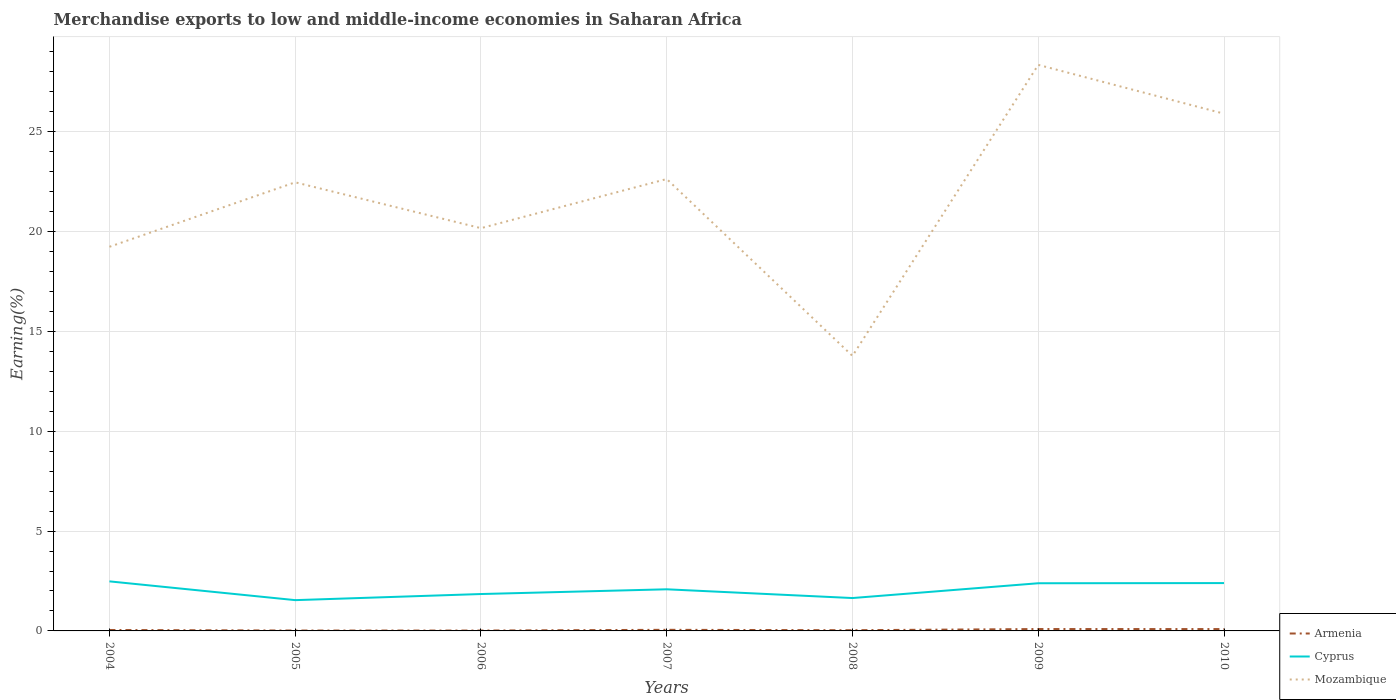Is the number of lines equal to the number of legend labels?
Provide a short and direct response. Yes. Across all years, what is the maximum percentage of amount earned from merchandise exports in Mozambique?
Provide a succinct answer. 13.77. In which year was the percentage of amount earned from merchandise exports in Mozambique maximum?
Provide a short and direct response. 2008. What is the total percentage of amount earned from merchandise exports in Mozambique in the graph?
Provide a short and direct response. -8.18. What is the difference between the highest and the second highest percentage of amount earned from merchandise exports in Cyprus?
Your answer should be compact. 0.94. Is the percentage of amount earned from merchandise exports in Armenia strictly greater than the percentage of amount earned from merchandise exports in Cyprus over the years?
Provide a succinct answer. Yes. How many lines are there?
Ensure brevity in your answer.  3. What is the difference between two consecutive major ticks on the Y-axis?
Keep it short and to the point. 5. Are the values on the major ticks of Y-axis written in scientific E-notation?
Give a very brief answer. No. Does the graph contain any zero values?
Your answer should be very brief. No. Where does the legend appear in the graph?
Your response must be concise. Bottom right. What is the title of the graph?
Provide a short and direct response. Merchandise exports to low and middle-income economies in Saharan Africa. Does "Turks and Caicos Islands" appear as one of the legend labels in the graph?
Provide a succinct answer. No. What is the label or title of the X-axis?
Your answer should be very brief. Years. What is the label or title of the Y-axis?
Give a very brief answer. Earning(%). What is the Earning(%) of Armenia in 2004?
Offer a terse response. 0.05. What is the Earning(%) of Cyprus in 2004?
Ensure brevity in your answer.  2.48. What is the Earning(%) of Mozambique in 2004?
Your answer should be compact. 19.24. What is the Earning(%) in Armenia in 2005?
Your response must be concise. 0.02. What is the Earning(%) of Cyprus in 2005?
Your answer should be very brief. 1.54. What is the Earning(%) of Mozambique in 2005?
Your response must be concise. 22.47. What is the Earning(%) of Armenia in 2006?
Offer a very short reply. 0.02. What is the Earning(%) of Cyprus in 2006?
Offer a terse response. 1.85. What is the Earning(%) of Mozambique in 2006?
Offer a very short reply. 20.17. What is the Earning(%) of Armenia in 2007?
Your answer should be very brief. 0.06. What is the Earning(%) in Cyprus in 2007?
Offer a very short reply. 2.08. What is the Earning(%) in Mozambique in 2007?
Give a very brief answer. 22.64. What is the Earning(%) in Armenia in 2008?
Keep it short and to the point. 0.04. What is the Earning(%) of Cyprus in 2008?
Provide a short and direct response. 1.65. What is the Earning(%) in Mozambique in 2008?
Your response must be concise. 13.77. What is the Earning(%) in Armenia in 2009?
Provide a short and direct response. 0.09. What is the Earning(%) of Cyprus in 2009?
Offer a very short reply. 2.39. What is the Earning(%) in Mozambique in 2009?
Provide a short and direct response. 28.35. What is the Earning(%) of Armenia in 2010?
Your answer should be very brief. 0.09. What is the Earning(%) of Cyprus in 2010?
Your answer should be compact. 2.4. What is the Earning(%) of Mozambique in 2010?
Provide a succinct answer. 25.91. Across all years, what is the maximum Earning(%) of Armenia?
Your answer should be very brief. 0.09. Across all years, what is the maximum Earning(%) in Cyprus?
Offer a terse response. 2.48. Across all years, what is the maximum Earning(%) in Mozambique?
Make the answer very short. 28.35. Across all years, what is the minimum Earning(%) in Armenia?
Make the answer very short. 0.02. Across all years, what is the minimum Earning(%) of Cyprus?
Your answer should be compact. 1.54. Across all years, what is the minimum Earning(%) of Mozambique?
Offer a terse response. 13.77. What is the total Earning(%) in Armenia in the graph?
Keep it short and to the point. 0.36. What is the total Earning(%) in Cyprus in the graph?
Make the answer very short. 14.39. What is the total Earning(%) in Mozambique in the graph?
Provide a succinct answer. 152.56. What is the difference between the Earning(%) of Armenia in 2004 and that in 2005?
Give a very brief answer. 0.03. What is the difference between the Earning(%) in Cyprus in 2004 and that in 2005?
Give a very brief answer. 0.94. What is the difference between the Earning(%) in Mozambique in 2004 and that in 2005?
Ensure brevity in your answer.  -3.23. What is the difference between the Earning(%) in Armenia in 2004 and that in 2006?
Your answer should be compact. 0.03. What is the difference between the Earning(%) of Cyprus in 2004 and that in 2006?
Give a very brief answer. 0.63. What is the difference between the Earning(%) of Mozambique in 2004 and that in 2006?
Offer a terse response. -0.93. What is the difference between the Earning(%) in Armenia in 2004 and that in 2007?
Your answer should be compact. -0.01. What is the difference between the Earning(%) of Cyprus in 2004 and that in 2007?
Ensure brevity in your answer.  0.4. What is the difference between the Earning(%) in Mozambique in 2004 and that in 2007?
Ensure brevity in your answer.  -3.39. What is the difference between the Earning(%) in Armenia in 2004 and that in 2008?
Your answer should be compact. 0.01. What is the difference between the Earning(%) in Cyprus in 2004 and that in 2008?
Offer a terse response. 0.84. What is the difference between the Earning(%) in Mozambique in 2004 and that in 2008?
Provide a succinct answer. 5.47. What is the difference between the Earning(%) of Armenia in 2004 and that in 2009?
Make the answer very short. -0.05. What is the difference between the Earning(%) of Cyprus in 2004 and that in 2009?
Make the answer very short. 0.09. What is the difference between the Earning(%) of Mozambique in 2004 and that in 2009?
Your response must be concise. -9.11. What is the difference between the Earning(%) in Armenia in 2004 and that in 2010?
Keep it short and to the point. -0.05. What is the difference between the Earning(%) of Cyprus in 2004 and that in 2010?
Provide a succinct answer. 0.09. What is the difference between the Earning(%) of Mozambique in 2004 and that in 2010?
Make the answer very short. -6.67. What is the difference between the Earning(%) of Armenia in 2005 and that in 2006?
Offer a terse response. 0. What is the difference between the Earning(%) of Cyprus in 2005 and that in 2006?
Your response must be concise. -0.31. What is the difference between the Earning(%) in Mozambique in 2005 and that in 2006?
Provide a short and direct response. 2.3. What is the difference between the Earning(%) of Armenia in 2005 and that in 2007?
Your answer should be very brief. -0.04. What is the difference between the Earning(%) of Cyprus in 2005 and that in 2007?
Keep it short and to the point. -0.54. What is the difference between the Earning(%) of Mozambique in 2005 and that in 2007?
Offer a terse response. -0.16. What is the difference between the Earning(%) in Armenia in 2005 and that in 2008?
Your response must be concise. -0.02. What is the difference between the Earning(%) of Cyprus in 2005 and that in 2008?
Your response must be concise. -0.1. What is the difference between the Earning(%) in Mozambique in 2005 and that in 2008?
Give a very brief answer. 8.7. What is the difference between the Earning(%) in Armenia in 2005 and that in 2009?
Your response must be concise. -0.07. What is the difference between the Earning(%) of Cyprus in 2005 and that in 2009?
Your answer should be very brief. -0.85. What is the difference between the Earning(%) of Mozambique in 2005 and that in 2009?
Your answer should be compact. -5.88. What is the difference between the Earning(%) in Armenia in 2005 and that in 2010?
Your response must be concise. -0.07. What is the difference between the Earning(%) in Cyprus in 2005 and that in 2010?
Keep it short and to the point. -0.85. What is the difference between the Earning(%) in Mozambique in 2005 and that in 2010?
Make the answer very short. -3.44. What is the difference between the Earning(%) in Armenia in 2006 and that in 2007?
Your answer should be very brief. -0.04. What is the difference between the Earning(%) in Cyprus in 2006 and that in 2007?
Ensure brevity in your answer.  -0.24. What is the difference between the Earning(%) in Mozambique in 2006 and that in 2007?
Ensure brevity in your answer.  -2.46. What is the difference between the Earning(%) in Armenia in 2006 and that in 2008?
Provide a short and direct response. -0.02. What is the difference between the Earning(%) of Cyprus in 2006 and that in 2008?
Provide a short and direct response. 0.2. What is the difference between the Earning(%) in Mozambique in 2006 and that in 2008?
Make the answer very short. 6.4. What is the difference between the Earning(%) in Armenia in 2006 and that in 2009?
Offer a terse response. -0.08. What is the difference between the Earning(%) in Cyprus in 2006 and that in 2009?
Your answer should be very brief. -0.54. What is the difference between the Earning(%) of Mozambique in 2006 and that in 2009?
Keep it short and to the point. -8.18. What is the difference between the Earning(%) in Armenia in 2006 and that in 2010?
Offer a very short reply. -0.07. What is the difference between the Earning(%) in Cyprus in 2006 and that in 2010?
Give a very brief answer. -0.55. What is the difference between the Earning(%) in Mozambique in 2006 and that in 2010?
Your answer should be compact. -5.73. What is the difference between the Earning(%) in Armenia in 2007 and that in 2008?
Ensure brevity in your answer.  0.02. What is the difference between the Earning(%) of Cyprus in 2007 and that in 2008?
Your response must be concise. 0.44. What is the difference between the Earning(%) in Mozambique in 2007 and that in 2008?
Ensure brevity in your answer.  8.86. What is the difference between the Earning(%) in Armenia in 2007 and that in 2009?
Your answer should be very brief. -0.04. What is the difference between the Earning(%) in Cyprus in 2007 and that in 2009?
Provide a succinct answer. -0.3. What is the difference between the Earning(%) of Mozambique in 2007 and that in 2009?
Your answer should be very brief. -5.72. What is the difference between the Earning(%) of Armenia in 2007 and that in 2010?
Your response must be concise. -0.04. What is the difference between the Earning(%) in Cyprus in 2007 and that in 2010?
Offer a terse response. -0.31. What is the difference between the Earning(%) in Mozambique in 2007 and that in 2010?
Provide a succinct answer. -3.27. What is the difference between the Earning(%) in Armenia in 2008 and that in 2009?
Provide a short and direct response. -0.06. What is the difference between the Earning(%) in Cyprus in 2008 and that in 2009?
Keep it short and to the point. -0.74. What is the difference between the Earning(%) of Mozambique in 2008 and that in 2009?
Give a very brief answer. -14.58. What is the difference between the Earning(%) of Armenia in 2008 and that in 2010?
Your answer should be very brief. -0.06. What is the difference between the Earning(%) in Cyprus in 2008 and that in 2010?
Give a very brief answer. -0.75. What is the difference between the Earning(%) in Mozambique in 2008 and that in 2010?
Make the answer very short. -12.13. What is the difference between the Earning(%) in Armenia in 2009 and that in 2010?
Ensure brevity in your answer.  0. What is the difference between the Earning(%) of Cyprus in 2009 and that in 2010?
Offer a terse response. -0.01. What is the difference between the Earning(%) in Mozambique in 2009 and that in 2010?
Your response must be concise. 2.45. What is the difference between the Earning(%) in Armenia in 2004 and the Earning(%) in Cyprus in 2005?
Your response must be concise. -1.5. What is the difference between the Earning(%) in Armenia in 2004 and the Earning(%) in Mozambique in 2005?
Give a very brief answer. -22.42. What is the difference between the Earning(%) in Cyprus in 2004 and the Earning(%) in Mozambique in 2005?
Offer a very short reply. -19.99. What is the difference between the Earning(%) of Armenia in 2004 and the Earning(%) of Cyprus in 2006?
Give a very brief answer. -1.8. What is the difference between the Earning(%) of Armenia in 2004 and the Earning(%) of Mozambique in 2006?
Keep it short and to the point. -20.13. What is the difference between the Earning(%) in Cyprus in 2004 and the Earning(%) in Mozambique in 2006?
Ensure brevity in your answer.  -17.69. What is the difference between the Earning(%) in Armenia in 2004 and the Earning(%) in Cyprus in 2007?
Offer a terse response. -2.04. What is the difference between the Earning(%) of Armenia in 2004 and the Earning(%) of Mozambique in 2007?
Ensure brevity in your answer.  -22.59. What is the difference between the Earning(%) in Cyprus in 2004 and the Earning(%) in Mozambique in 2007?
Provide a succinct answer. -20.15. What is the difference between the Earning(%) in Armenia in 2004 and the Earning(%) in Cyprus in 2008?
Offer a very short reply. -1.6. What is the difference between the Earning(%) of Armenia in 2004 and the Earning(%) of Mozambique in 2008?
Make the answer very short. -13.73. What is the difference between the Earning(%) in Cyprus in 2004 and the Earning(%) in Mozambique in 2008?
Your response must be concise. -11.29. What is the difference between the Earning(%) in Armenia in 2004 and the Earning(%) in Cyprus in 2009?
Offer a terse response. -2.34. What is the difference between the Earning(%) of Armenia in 2004 and the Earning(%) of Mozambique in 2009?
Your response must be concise. -28.31. What is the difference between the Earning(%) of Cyprus in 2004 and the Earning(%) of Mozambique in 2009?
Provide a succinct answer. -25.87. What is the difference between the Earning(%) of Armenia in 2004 and the Earning(%) of Cyprus in 2010?
Make the answer very short. -2.35. What is the difference between the Earning(%) in Armenia in 2004 and the Earning(%) in Mozambique in 2010?
Provide a succinct answer. -25.86. What is the difference between the Earning(%) of Cyprus in 2004 and the Earning(%) of Mozambique in 2010?
Keep it short and to the point. -23.43. What is the difference between the Earning(%) in Armenia in 2005 and the Earning(%) in Cyprus in 2006?
Offer a very short reply. -1.83. What is the difference between the Earning(%) in Armenia in 2005 and the Earning(%) in Mozambique in 2006?
Your response must be concise. -20.16. What is the difference between the Earning(%) of Cyprus in 2005 and the Earning(%) of Mozambique in 2006?
Keep it short and to the point. -18.63. What is the difference between the Earning(%) of Armenia in 2005 and the Earning(%) of Cyprus in 2007?
Make the answer very short. -2.07. What is the difference between the Earning(%) of Armenia in 2005 and the Earning(%) of Mozambique in 2007?
Your response must be concise. -22.62. What is the difference between the Earning(%) in Cyprus in 2005 and the Earning(%) in Mozambique in 2007?
Your response must be concise. -21.09. What is the difference between the Earning(%) of Armenia in 2005 and the Earning(%) of Cyprus in 2008?
Ensure brevity in your answer.  -1.63. What is the difference between the Earning(%) of Armenia in 2005 and the Earning(%) of Mozambique in 2008?
Your response must be concise. -13.76. What is the difference between the Earning(%) of Cyprus in 2005 and the Earning(%) of Mozambique in 2008?
Your response must be concise. -12.23. What is the difference between the Earning(%) in Armenia in 2005 and the Earning(%) in Cyprus in 2009?
Make the answer very short. -2.37. What is the difference between the Earning(%) in Armenia in 2005 and the Earning(%) in Mozambique in 2009?
Your answer should be very brief. -28.34. What is the difference between the Earning(%) of Cyprus in 2005 and the Earning(%) of Mozambique in 2009?
Ensure brevity in your answer.  -26.81. What is the difference between the Earning(%) in Armenia in 2005 and the Earning(%) in Cyprus in 2010?
Give a very brief answer. -2.38. What is the difference between the Earning(%) of Armenia in 2005 and the Earning(%) of Mozambique in 2010?
Keep it short and to the point. -25.89. What is the difference between the Earning(%) of Cyprus in 2005 and the Earning(%) of Mozambique in 2010?
Provide a succinct answer. -24.37. What is the difference between the Earning(%) in Armenia in 2006 and the Earning(%) in Cyprus in 2007?
Give a very brief answer. -2.07. What is the difference between the Earning(%) in Armenia in 2006 and the Earning(%) in Mozambique in 2007?
Offer a very short reply. -22.62. What is the difference between the Earning(%) of Cyprus in 2006 and the Earning(%) of Mozambique in 2007?
Keep it short and to the point. -20.79. What is the difference between the Earning(%) of Armenia in 2006 and the Earning(%) of Cyprus in 2008?
Provide a succinct answer. -1.63. What is the difference between the Earning(%) in Armenia in 2006 and the Earning(%) in Mozambique in 2008?
Provide a short and direct response. -13.76. What is the difference between the Earning(%) in Cyprus in 2006 and the Earning(%) in Mozambique in 2008?
Give a very brief answer. -11.93. What is the difference between the Earning(%) in Armenia in 2006 and the Earning(%) in Cyprus in 2009?
Provide a short and direct response. -2.37. What is the difference between the Earning(%) of Armenia in 2006 and the Earning(%) of Mozambique in 2009?
Make the answer very short. -28.34. What is the difference between the Earning(%) of Cyprus in 2006 and the Earning(%) of Mozambique in 2009?
Your answer should be compact. -26.51. What is the difference between the Earning(%) of Armenia in 2006 and the Earning(%) of Cyprus in 2010?
Give a very brief answer. -2.38. What is the difference between the Earning(%) of Armenia in 2006 and the Earning(%) of Mozambique in 2010?
Make the answer very short. -25.89. What is the difference between the Earning(%) of Cyprus in 2006 and the Earning(%) of Mozambique in 2010?
Offer a very short reply. -24.06. What is the difference between the Earning(%) of Armenia in 2007 and the Earning(%) of Cyprus in 2008?
Provide a short and direct response. -1.59. What is the difference between the Earning(%) of Armenia in 2007 and the Earning(%) of Mozambique in 2008?
Your answer should be very brief. -13.72. What is the difference between the Earning(%) of Cyprus in 2007 and the Earning(%) of Mozambique in 2008?
Provide a short and direct response. -11.69. What is the difference between the Earning(%) in Armenia in 2007 and the Earning(%) in Cyprus in 2009?
Provide a short and direct response. -2.33. What is the difference between the Earning(%) in Armenia in 2007 and the Earning(%) in Mozambique in 2009?
Ensure brevity in your answer.  -28.3. What is the difference between the Earning(%) of Cyprus in 2007 and the Earning(%) of Mozambique in 2009?
Ensure brevity in your answer.  -26.27. What is the difference between the Earning(%) of Armenia in 2007 and the Earning(%) of Cyprus in 2010?
Ensure brevity in your answer.  -2.34. What is the difference between the Earning(%) in Armenia in 2007 and the Earning(%) in Mozambique in 2010?
Offer a terse response. -25.85. What is the difference between the Earning(%) of Cyprus in 2007 and the Earning(%) of Mozambique in 2010?
Make the answer very short. -23.82. What is the difference between the Earning(%) in Armenia in 2008 and the Earning(%) in Cyprus in 2009?
Your answer should be compact. -2.35. What is the difference between the Earning(%) of Armenia in 2008 and the Earning(%) of Mozambique in 2009?
Your answer should be compact. -28.32. What is the difference between the Earning(%) of Cyprus in 2008 and the Earning(%) of Mozambique in 2009?
Your response must be concise. -26.71. What is the difference between the Earning(%) in Armenia in 2008 and the Earning(%) in Cyprus in 2010?
Offer a terse response. -2.36. What is the difference between the Earning(%) in Armenia in 2008 and the Earning(%) in Mozambique in 2010?
Offer a very short reply. -25.87. What is the difference between the Earning(%) of Cyprus in 2008 and the Earning(%) of Mozambique in 2010?
Offer a very short reply. -24.26. What is the difference between the Earning(%) in Armenia in 2009 and the Earning(%) in Cyprus in 2010?
Provide a short and direct response. -2.3. What is the difference between the Earning(%) in Armenia in 2009 and the Earning(%) in Mozambique in 2010?
Offer a very short reply. -25.81. What is the difference between the Earning(%) of Cyprus in 2009 and the Earning(%) of Mozambique in 2010?
Your answer should be compact. -23.52. What is the average Earning(%) of Armenia per year?
Your answer should be compact. 0.05. What is the average Earning(%) in Cyprus per year?
Offer a terse response. 2.06. What is the average Earning(%) in Mozambique per year?
Keep it short and to the point. 21.79. In the year 2004, what is the difference between the Earning(%) in Armenia and Earning(%) in Cyprus?
Keep it short and to the point. -2.44. In the year 2004, what is the difference between the Earning(%) of Armenia and Earning(%) of Mozambique?
Keep it short and to the point. -19.2. In the year 2004, what is the difference between the Earning(%) in Cyprus and Earning(%) in Mozambique?
Provide a short and direct response. -16.76. In the year 2005, what is the difference between the Earning(%) in Armenia and Earning(%) in Cyprus?
Provide a succinct answer. -1.52. In the year 2005, what is the difference between the Earning(%) of Armenia and Earning(%) of Mozambique?
Your response must be concise. -22.45. In the year 2005, what is the difference between the Earning(%) of Cyprus and Earning(%) of Mozambique?
Your response must be concise. -20.93. In the year 2006, what is the difference between the Earning(%) of Armenia and Earning(%) of Cyprus?
Offer a terse response. -1.83. In the year 2006, what is the difference between the Earning(%) of Armenia and Earning(%) of Mozambique?
Give a very brief answer. -20.16. In the year 2006, what is the difference between the Earning(%) in Cyprus and Earning(%) in Mozambique?
Keep it short and to the point. -18.33. In the year 2007, what is the difference between the Earning(%) in Armenia and Earning(%) in Cyprus?
Your answer should be very brief. -2.03. In the year 2007, what is the difference between the Earning(%) in Armenia and Earning(%) in Mozambique?
Provide a succinct answer. -22.58. In the year 2007, what is the difference between the Earning(%) of Cyprus and Earning(%) of Mozambique?
Ensure brevity in your answer.  -20.55. In the year 2008, what is the difference between the Earning(%) in Armenia and Earning(%) in Cyprus?
Your answer should be compact. -1.61. In the year 2008, what is the difference between the Earning(%) in Armenia and Earning(%) in Mozambique?
Ensure brevity in your answer.  -13.74. In the year 2008, what is the difference between the Earning(%) of Cyprus and Earning(%) of Mozambique?
Offer a very short reply. -12.13. In the year 2009, what is the difference between the Earning(%) in Armenia and Earning(%) in Cyprus?
Keep it short and to the point. -2.29. In the year 2009, what is the difference between the Earning(%) of Armenia and Earning(%) of Mozambique?
Offer a terse response. -28.26. In the year 2009, what is the difference between the Earning(%) in Cyprus and Earning(%) in Mozambique?
Offer a terse response. -25.97. In the year 2010, what is the difference between the Earning(%) in Armenia and Earning(%) in Cyprus?
Make the answer very short. -2.3. In the year 2010, what is the difference between the Earning(%) of Armenia and Earning(%) of Mozambique?
Give a very brief answer. -25.82. In the year 2010, what is the difference between the Earning(%) in Cyprus and Earning(%) in Mozambique?
Offer a terse response. -23.51. What is the ratio of the Earning(%) in Armenia in 2004 to that in 2005?
Keep it short and to the point. 2.38. What is the ratio of the Earning(%) of Cyprus in 2004 to that in 2005?
Your response must be concise. 1.61. What is the ratio of the Earning(%) of Mozambique in 2004 to that in 2005?
Provide a succinct answer. 0.86. What is the ratio of the Earning(%) in Armenia in 2004 to that in 2006?
Give a very brief answer. 2.49. What is the ratio of the Earning(%) in Cyprus in 2004 to that in 2006?
Your answer should be compact. 1.34. What is the ratio of the Earning(%) of Mozambique in 2004 to that in 2006?
Offer a terse response. 0.95. What is the ratio of the Earning(%) of Armenia in 2004 to that in 2007?
Provide a short and direct response. 0.84. What is the ratio of the Earning(%) in Cyprus in 2004 to that in 2007?
Your answer should be compact. 1.19. What is the ratio of the Earning(%) of Mozambique in 2004 to that in 2007?
Give a very brief answer. 0.85. What is the ratio of the Earning(%) in Armenia in 2004 to that in 2008?
Offer a terse response. 1.31. What is the ratio of the Earning(%) in Cyprus in 2004 to that in 2008?
Keep it short and to the point. 1.51. What is the ratio of the Earning(%) in Mozambique in 2004 to that in 2008?
Offer a terse response. 1.4. What is the ratio of the Earning(%) in Armenia in 2004 to that in 2009?
Your answer should be very brief. 0.49. What is the ratio of the Earning(%) of Cyprus in 2004 to that in 2009?
Provide a succinct answer. 1.04. What is the ratio of the Earning(%) of Mozambique in 2004 to that in 2009?
Provide a short and direct response. 0.68. What is the ratio of the Earning(%) of Armenia in 2004 to that in 2010?
Provide a short and direct response. 0.5. What is the ratio of the Earning(%) of Cyprus in 2004 to that in 2010?
Make the answer very short. 1.04. What is the ratio of the Earning(%) of Mozambique in 2004 to that in 2010?
Make the answer very short. 0.74. What is the ratio of the Earning(%) in Armenia in 2005 to that in 2006?
Your answer should be compact. 1.05. What is the ratio of the Earning(%) in Cyprus in 2005 to that in 2006?
Your answer should be very brief. 0.83. What is the ratio of the Earning(%) in Mozambique in 2005 to that in 2006?
Ensure brevity in your answer.  1.11. What is the ratio of the Earning(%) of Armenia in 2005 to that in 2007?
Keep it short and to the point. 0.35. What is the ratio of the Earning(%) of Cyprus in 2005 to that in 2007?
Make the answer very short. 0.74. What is the ratio of the Earning(%) of Armenia in 2005 to that in 2008?
Make the answer very short. 0.55. What is the ratio of the Earning(%) in Cyprus in 2005 to that in 2008?
Your answer should be very brief. 0.94. What is the ratio of the Earning(%) of Mozambique in 2005 to that in 2008?
Offer a terse response. 1.63. What is the ratio of the Earning(%) in Armenia in 2005 to that in 2009?
Provide a short and direct response. 0.21. What is the ratio of the Earning(%) in Cyprus in 2005 to that in 2009?
Offer a terse response. 0.65. What is the ratio of the Earning(%) of Mozambique in 2005 to that in 2009?
Provide a succinct answer. 0.79. What is the ratio of the Earning(%) of Armenia in 2005 to that in 2010?
Ensure brevity in your answer.  0.21. What is the ratio of the Earning(%) of Cyprus in 2005 to that in 2010?
Keep it short and to the point. 0.64. What is the ratio of the Earning(%) in Mozambique in 2005 to that in 2010?
Provide a short and direct response. 0.87. What is the ratio of the Earning(%) of Armenia in 2006 to that in 2007?
Ensure brevity in your answer.  0.34. What is the ratio of the Earning(%) in Cyprus in 2006 to that in 2007?
Provide a short and direct response. 0.89. What is the ratio of the Earning(%) of Mozambique in 2006 to that in 2007?
Your response must be concise. 0.89. What is the ratio of the Earning(%) of Armenia in 2006 to that in 2008?
Offer a very short reply. 0.53. What is the ratio of the Earning(%) of Cyprus in 2006 to that in 2008?
Keep it short and to the point. 1.12. What is the ratio of the Earning(%) of Mozambique in 2006 to that in 2008?
Provide a succinct answer. 1.46. What is the ratio of the Earning(%) in Armenia in 2006 to that in 2009?
Make the answer very short. 0.2. What is the ratio of the Earning(%) of Cyprus in 2006 to that in 2009?
Provide a succinct answer. 0.77. What is the ratio of the Earning(%) in Mozambique in 2006 to that in 2009?
Offer a terse response. 0.71. What is the ratio of the Earning(%) in Armenia in 2006 to that in 2010?
Keep it short and to the point. 0.2. What is the ratio of the Earning(%) in Cyprus in 2006 to that in 2010?
Give a very brief answer. 0.77. What is the ratio of the Earning(%) in Mozambique in 2006 to that in 2010?
Give a very brief answer. 0.78. What is the ratio of the Earning(%) in Armenia in 2007 to that in 2008?
Offer a terse response. 1.55. What is the ratio of the Earning(%) of Cyprus in 2007 to that in 2008?
Your answer should be very brief. 1.27. What is the ratio of the Earning(%) in Mozambique in 2007 to that in 2008?
Offer a terse response. 1.64. What is the ratio of the Earning(%) of Armenia in 2007 to that in 2009?
Give a very brief answer. 0.59. What is the ratio of the Earning(%) in Cyprus in 2007 to that in 2009?
Make the answer very short. 0.87. What is the ratio of the Earning(%) in Mozambique in 2007 to that in 2009?
Provide a succinct answer. 0.8. What is the ratio of the Earning(%) of Armenia in 2007 to that in 2010?
Offer a very short reply. 0.6. What is the ratio of the Earning(%) of Cyprus in 2007 to that in 2010?
Provide a succinct answer. 0.87. What is the ratio of the Earning(%) of Mozambique in 2007 to that in 2010?
Offer a terse response. 0.87. What is the ratio of the Earning(%) of Armenia in 2008 to that in 2009?
Give a very brief answer. 0.38. What is the ratio of the Earning(%) in Cyprus in 2008 to that in 2009?
Offer a terse response. 0.69. What is the ratio of the Earning(%) in Mozambique in 2008 to that in 2009?
Give a very brief answer. 0.49. What is the ratio of the Earning(%) of Armenia in 2008 to that in 2010?
Your answer should be very brief. 0.39. What is the ratio of the Earning(%) in Cyprus in 2008 to that in 2010?
Offer a terse response. 0.69. What is the ratio of the Earning(%) in Mozambique in 2008 to that in 2010?
Ensure brevity in your answer.  0.53. What is the ratio of the Earning(%) of Armenia in 2009 to that in 2010?
Your answer should be compact. 1.02. What is the ratio of the Earning(%) in Cyprus in 2009 to that in 2010?
Offer a terse response. 1. What is the ratio of the Earning(%) of Mozambique in 2009 to that in 2010?
Ensure brevity in your answer.  1.09. What is the difference between the highest and the second highest Earning(%) in Armenia?
Give a very brief answer. 0. What is the difference between the highest and the second highest Earning(%) in Cyprus?
Your answer should be compact. 0.09. What is the difference between the highest and the second highest Earning(%) in Mozambique?
Offer a terse response. 2.45. What is the difference between the highest and the lowest Earning(%) in Armenia?
Make the answer very short. 0.08. What is the difference between the highest and the lowest Earning(%) of Cyprus?
Offer a terse response. 0.94. What is the difference between the highest and the lowest Earning(%) in Mozambique?
Your answer should be very brief. 14.58. 